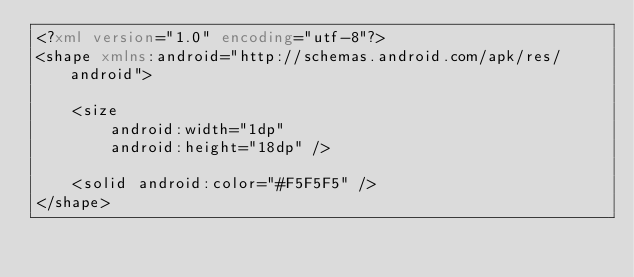<code> <loc_0><loc_0><loc_500><loc_500><_XML_><?xml version="1.0" encoding="utf-8"?>
<shape xmlns:android="http://schemas.android.com/apk/res/android">

    <size
        android:width="1dp"
        android:height="18dp" />

    <solid android:color="#F5F5F5" />
</shape></code> 